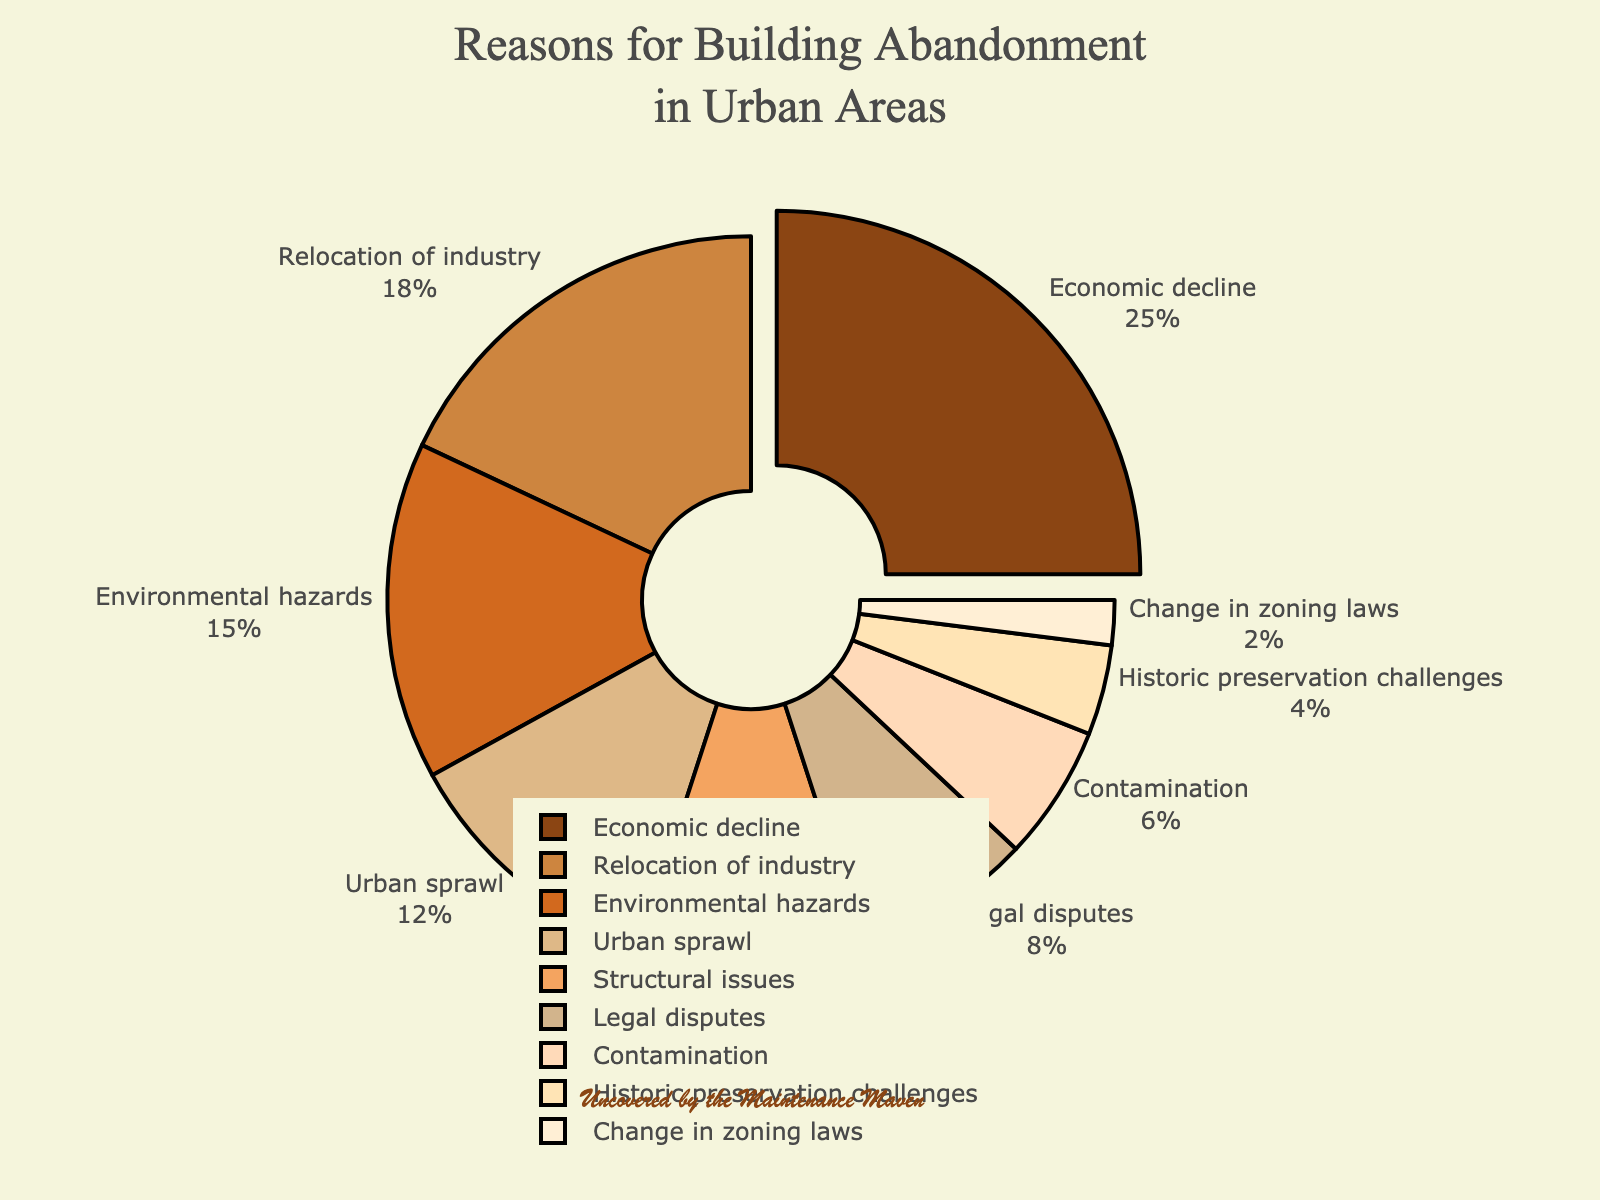Which reason accounts for the largest percentage of building abandonment? The reason with the largest percentage is highlighted and pulled out from the pie chart. Here, "Economic decline" is the most prominent section.
Answer: Economic decline What reasons collectively represent more than 50% of building abandonment? Summing up the top percentages: Economic decline (25%), Relocation of industry (18%), and Environmental hazards (15%) gives: 25 + 18 + 15 = 58%, which is more than half.
Answer: Economic decline, Relocation of industry, Environmental hazards How much more significant is Economic decline than Structural issues? Economic decline has 25%, and Structural issues have 10%. So, the difference is 25 - 10 = 15%.
Answer: 15% Is the percentage for Environmental hazards more than Urban sprawl? Environmental hazards stand at 15%, while Urban sprawl is at 12%. Comparing the two: 15 > 12.
Answer: Yes What is the combined percentage of Legal disputes and Contamination? Adding Legal disputes (8%) and Contamination (6%) yields: 8 + 6 = 14%.
Answer: 14% Which reason has the smallest percentage of building abandonment? The reason with the smallest percentage in the pie chart is "Change in zoning laws" at 2%.
Answer: Change in zoning laws Which reasons have percentages less than 10%? The reasons with percentages below 10% are Structural issues (10%), Legal disputes (8%), Contamination (6%), Historic preservation challenges (4%), and Change in zoning laws (2%).
Answer: Structural issues, Legal disputes, Contamination, Historic preservation challenges, Change in zoning laws Are Historic preservation challenges more significant than Contamination in building abandonment? Checking the chart, Historic preservation challenges are at 4%, while Contamination is higher at 6%.
Answer: No What is the total percentage of reasons other than Economic decline? Total percentage is 100%, and subtracting Economic decline (25%) gives: 100 - 25 = 75%.
Answer: 75% How does the percentage for Urban sprawl compare with Environmental hazards? Urban sprawl is at 12%, and Environmental hazards are 15%. Comparing the two: 12 < 15.
Answer: Less 